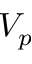<formula> <loc_0><loc_0><loc_500><loc_500>V _ { p }</formula> 